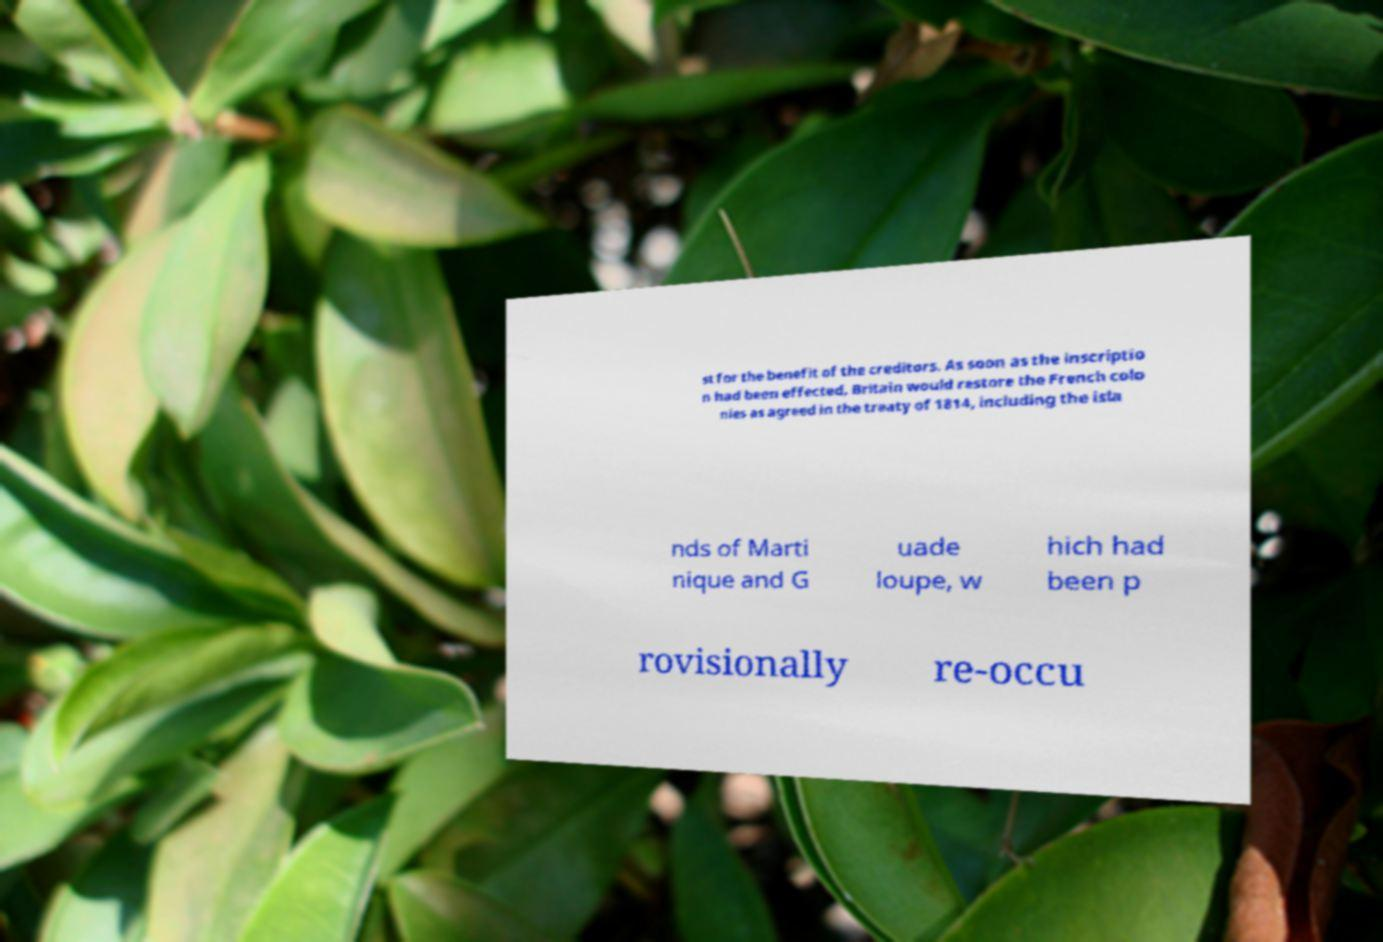Please identify and transcribe the text found in this image. st for the benefit of the creditors. As soon as the inscriptio n had been effected, Britain would restore the French colo nies as agreed in the treaty of 1814, including the isla nds of Marti nique and G uade loupe, w hich had been p rovisionally re-occu 